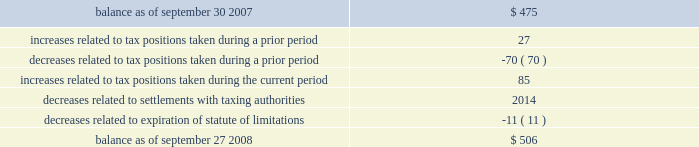Table of contents notes to consolidated financial statements ( continued ) note 5 2014income taxes ( continued ) fin 48 in the first quarter of 2008 , the company adopted fin 48 .
Upon adoption of fin 48 , the company 2019s cumulative effect of a change in accounting principle resulted in an increase to retained earnings of $ 11 million .
The company had historically classified interest and penalties and unrecognized tax benefits as current liabilities .
Beginning with the adoption of fin 48 , the company classifies gross interest and penalties and unrecognized tax benefits that are not expected to result in payment or receipt of cash within one year as non-current liabilities in the consolidated balance sheet .
The total amount of gross unrecognized tax benefits as of the date of adoption of fin 48 was $ 475 million , of which $ 209 million , if recognized , would affect the company 2019s effective tax rate .
As of september 27 , 2008 , the total amount of gross unrecognized tax benefits was $ 506 million , of which $ 253 million , if recognized , would affect the company 2019s effective tax rate .
The company 2019s total gross unrecognized tax benefits are classified as non-current liabilities in the consolidated balance sheet .
The aggregate changes in the balance of gross unrecognized tax benefits , which excludes interest and penalties , for the fiscal year ended september 27 , 2008 , is as follows ( in millions ) : the company 2019s policy to include interest and penalties related to unrecognized tax benefits within the provision for income taxes did not change as a result of adopting fin 48 .
As of the date of adoption , the company had accrued $ 203 million for the gross interest and penalties relating to unrecognized tax benefits .
As of september 27 , 2008 , the total amount of gross interest and penalties accrued was $ 219 million , which is classified as non-current liabilities in the consolidated balance sheet .
In 2008 , the company recognized interest expense in connection with tax matters of $ 16 million .
The company is subject to taxation and files income tax returns in the u.s .
Federal jurisdiction and in many state and foreign jurisdictions .
For u.s .
Federal income tax purposes , all years prior to 2002 are closed .
The years 2002-2003 have been examined by the internal revenue service ( the 201cirs 201d ) and disputed issues have been taken to administrative appeals .
The irs is currently examining the 2004-2006 years .
In addition , the company is also subject to audits by state , local , and foreign tax authorities .
In major states and major foreign jurisdictions , the years subsequent to 1988 and 2000 , respectively , generally remain open and could be subject to examination by the taxing authorities .
Management believes that an adequate provision has been made for any adjustments that may result from tax examinations .
However , the outcome of tax audits cannot be predicted with certainty .
If any issues addressed in the company 2019s tax audits are resolved in a manner not consistent with management 2019s expectations , the company could be required to adjust its provision for income tax in the period such resolution occurs .
Although timing of the resolution and/or closure of audits is highly uncertain , the company does not believe it is reasonably possible that its unrecognized tax benefits would materially change in the next 12 months. .

What percent of the total unrecognized tax benefits is increases related to tax positions taken during a prior period? 
Computations: (27 / 506)
Answer: 0.05336. 